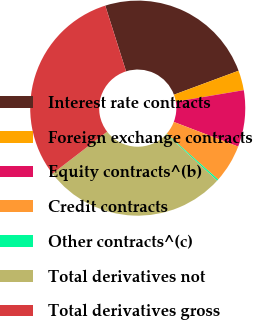<chart> <loc_0><loc_0><loc_500><loc_500><pie_chart><fcel>Interest rate contracts<fcel>Foreign exchange contracts<fcel>Equity contracts^(b)<fcel>Credit contracts<fcel>Other contracts^(c)<fcel>Total derivatives not<fcel>Total derivatives gross<nl><fcel>24.23%<fcel>2.98%<fcel>8.49%<fcel>5.73%<fcel>0.22%<fcel>27.8%<fcel>30.55%<nl></chart> 